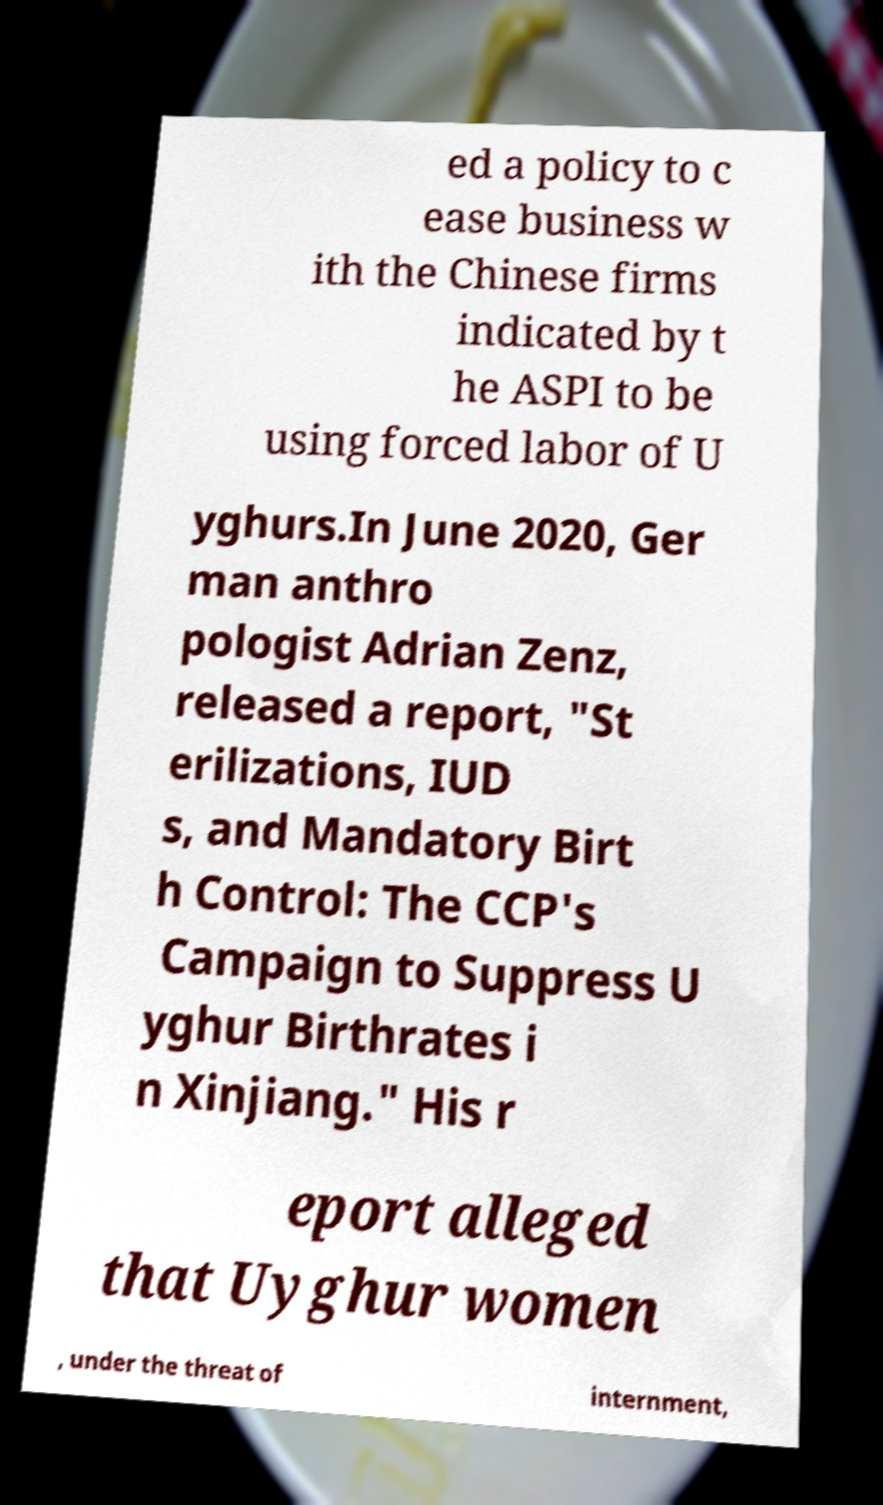What messages or text are displayed in this image? I need them in a readable, typed format. ed a policy to c ease business w ith the Chinese firms indicated by t he ASPI to be using forced labor of U yghurs.In June 2020, Ger man anthro pologist Adrian Zenz, released a report, "St erilizations, IUD s, and Mandatory Birt h Control: The CCP's Campaign to Suppress U yghur Birthrates i n Xinjiang." His r eport alleged that Uyghur women , under the threat of internment, 